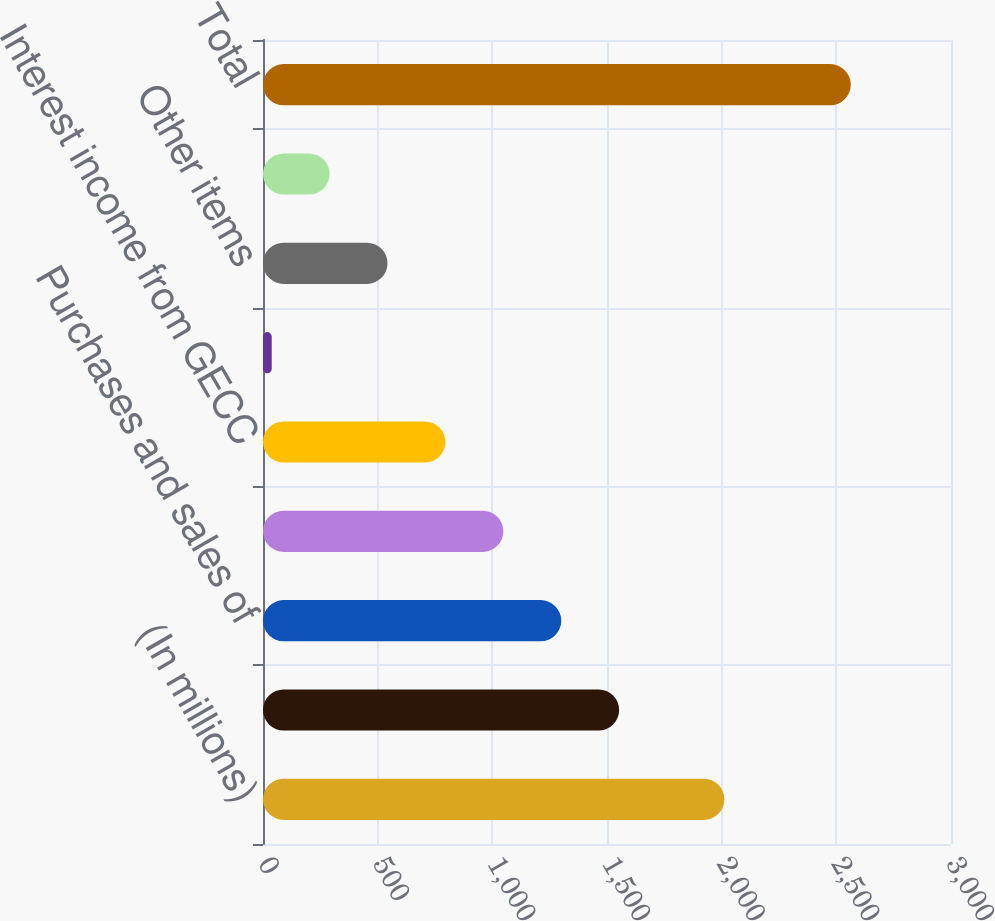Convert chart. <chart><loc_0><loc_0><loc_500><loc_500><bar_chart><fcel>(In millions)<fcel>Associated companies (a)<fcel>Purchases and sales of<fcel>Licensing and royalty income<fcel>Interest income from GECC<fcel>Marketable securities and bank<fcel>Other items<fcel>ELIMINATIONS<fcel>Total<nl><fcel>2012<fcel>1553<fcel>1300.5<fcel>1048<fcel>795.5<fcel>38<fcel>543<fcel>290.5<fcel>2563<nl></chart> 